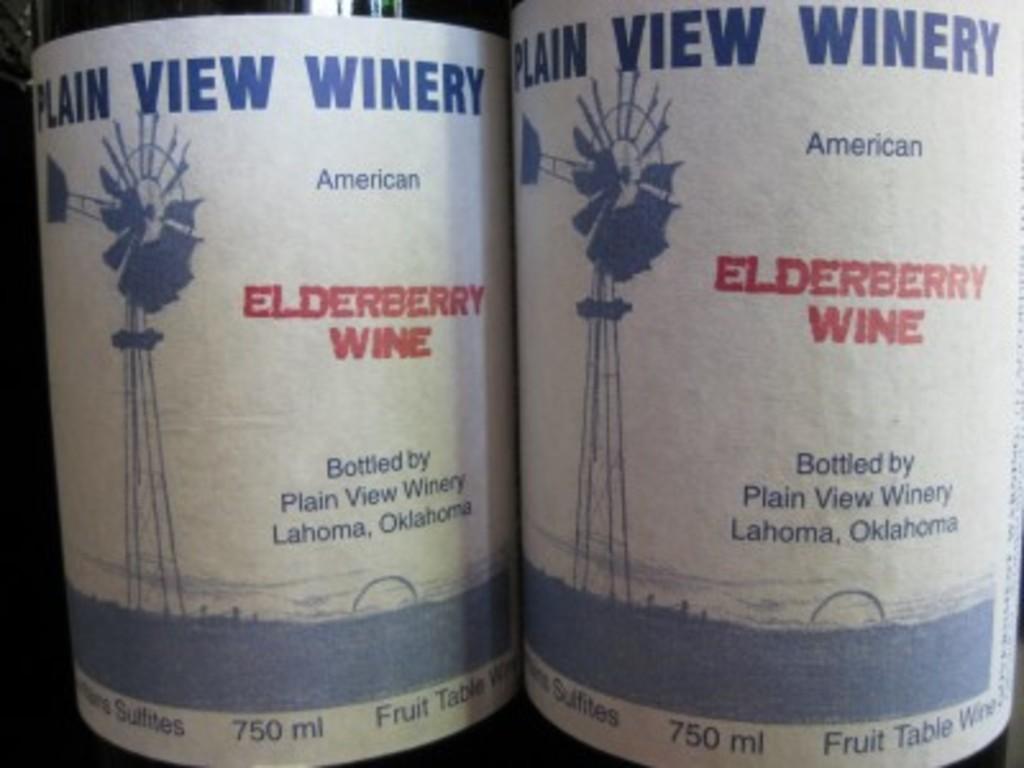Where is the wine bottled?
Provide a succinct answer. Lahoma, oklahoma. 